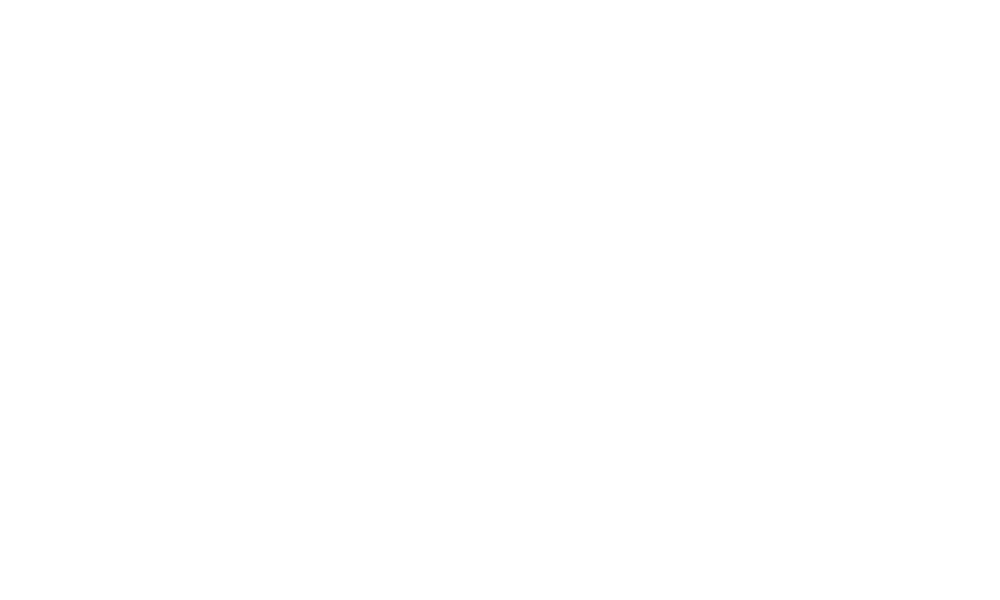<chart> <loc_0><loc_0><loc_500><loc_500><pie_chart><fcel>Cash paid during the period<nl><fcel>100.0%<nl></chart> 